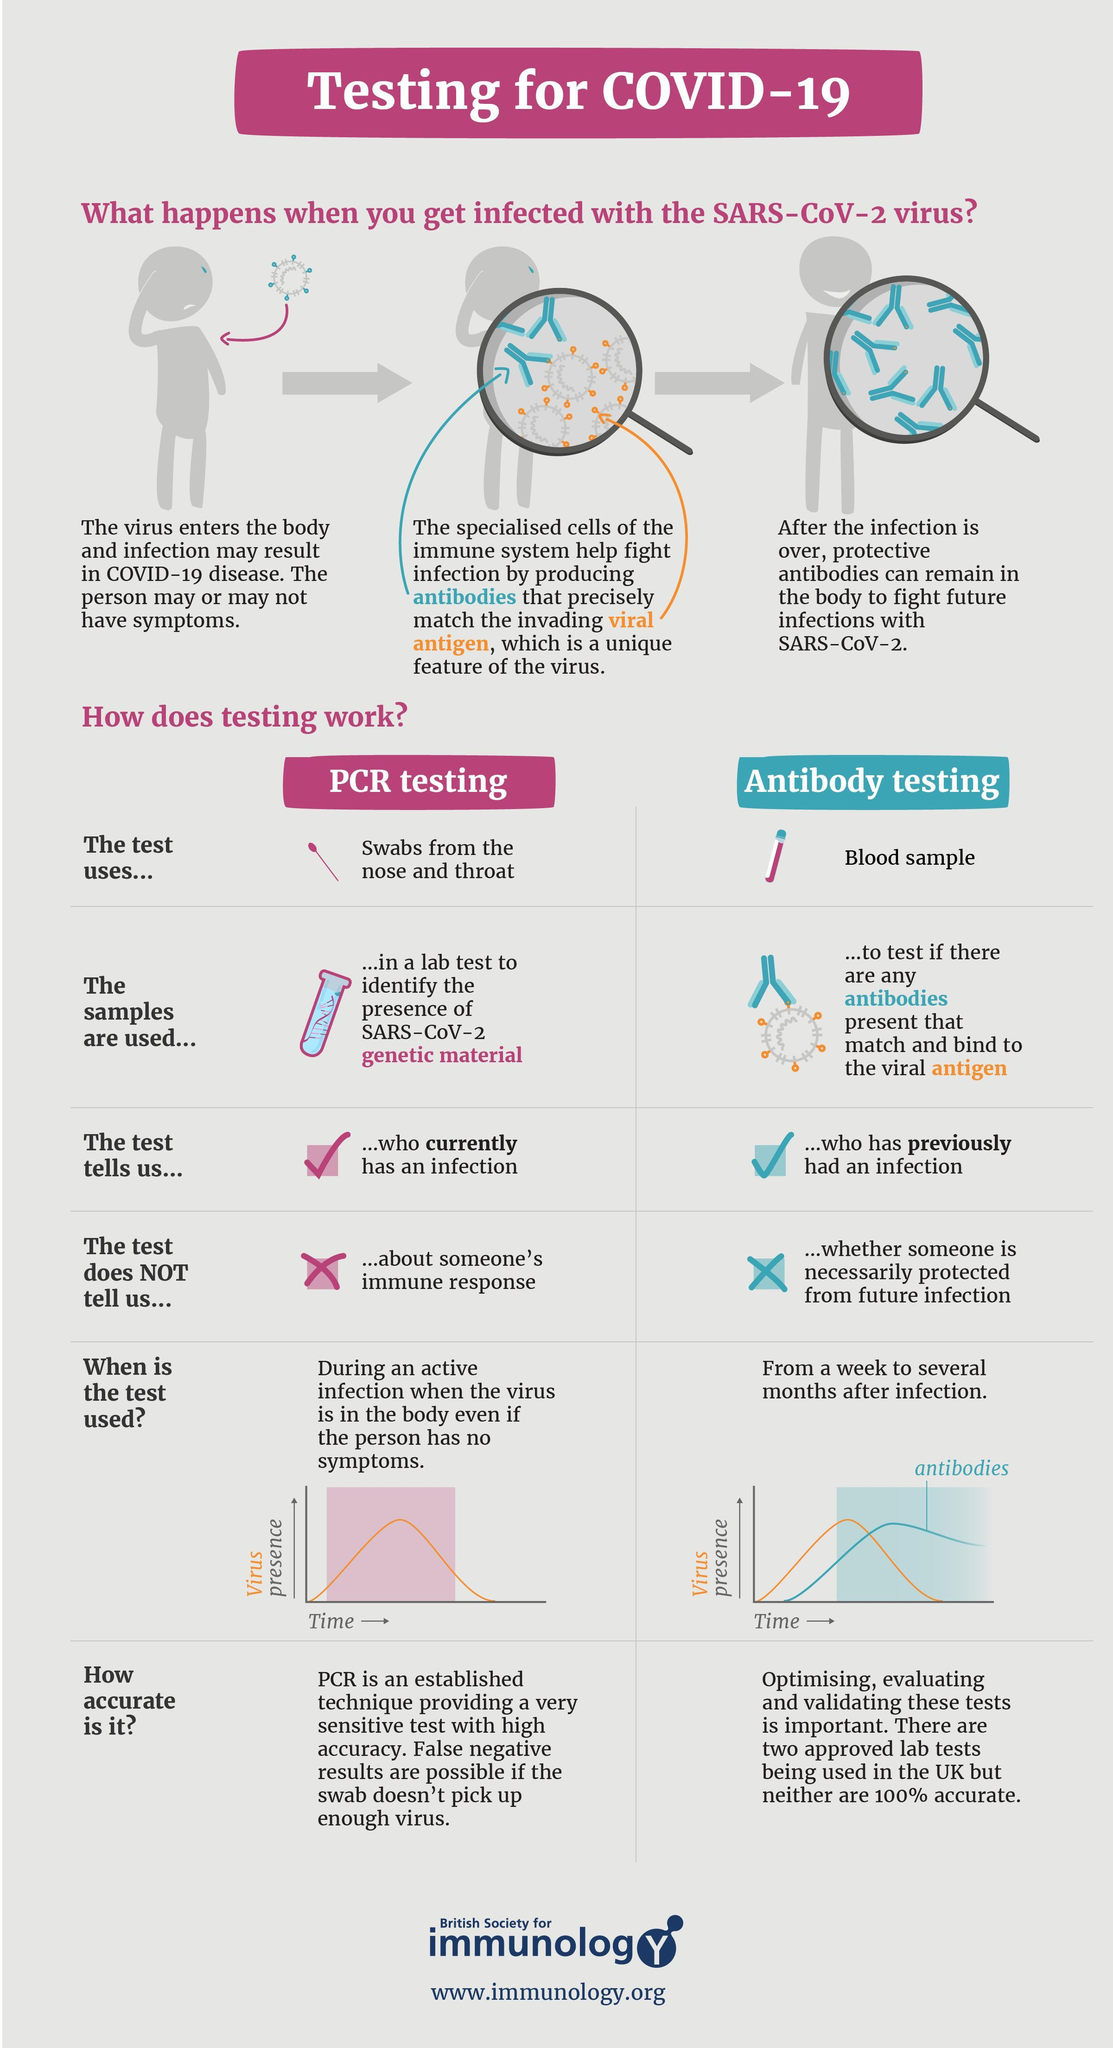Which test is used to identify, whether a person 'currently' has an infection?
Answer the question with a short phrase. PCR testing What does the antibody test use for testing? Blood sample Which test is used, a week or several months after the infection? Antibody testing Which test is used during an active infection? PCR testing Which test identifies the presence of antibodies that bind to the viral antigen? Antibody testing Which test involves identifying the presence of SARS-CoV-2 genetic material? PCR testing What does the PCR test 'not' tell us? About someone's immune response What does the PCR test use for testing? Swabs from the nose and throat What do the antibodies bind to? Viral antigen Which test is used to identify a person who previously had an infection? Antibody testing What does antibody test 'not' tell us? Whether someone is necessarily protected from future infection 